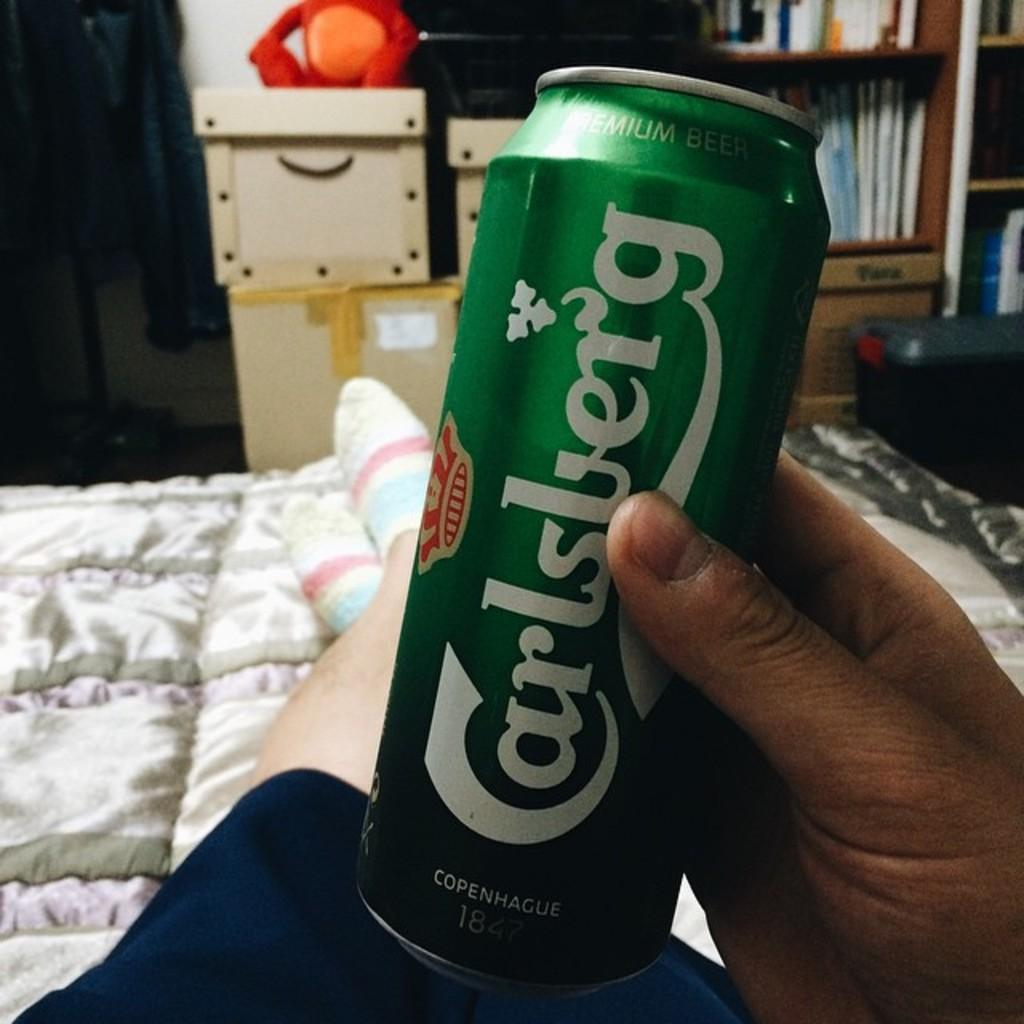<image>
Create a compact narrative representing the image presented. A green Carlsberg Premium Beer can is being held by somebody lounging in bed 